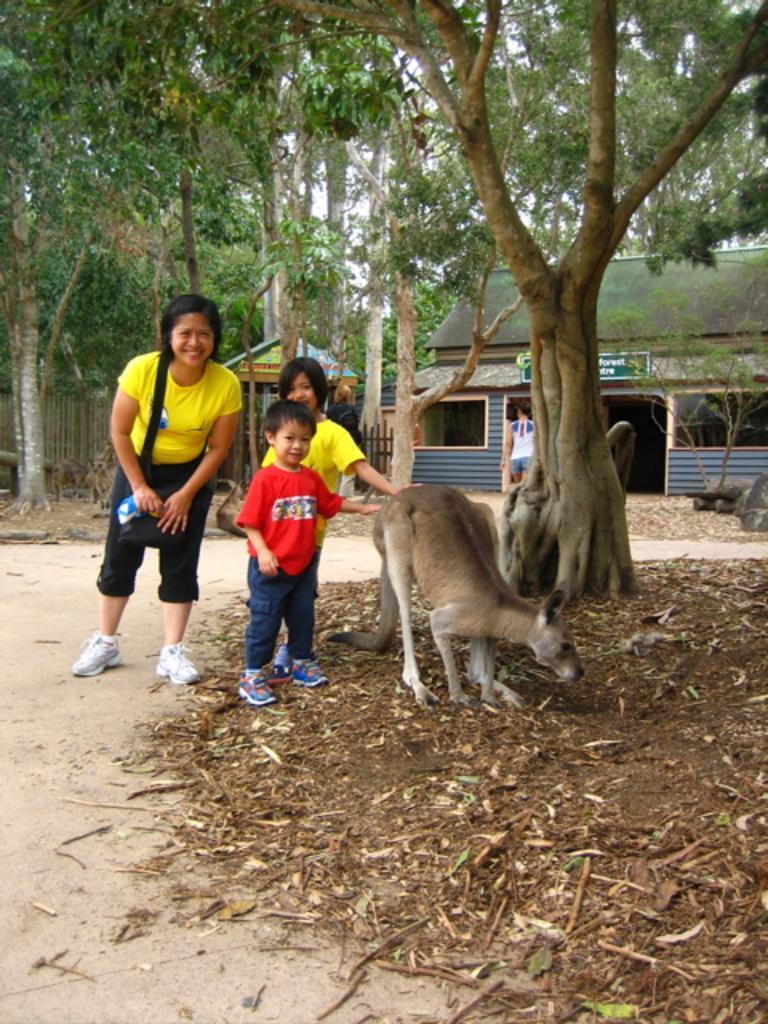Could you give a brief overview of what you see in this image? In this picture there is a woman who is wearing t-shirt, trouser and shoes. Beside her there are two children who are standing near to the kangaroo. In the back there is a man who is standing near to the shed. In the background I can see many trees, plants and grass. In the left background I can see the fencing. Here it's a sky. 